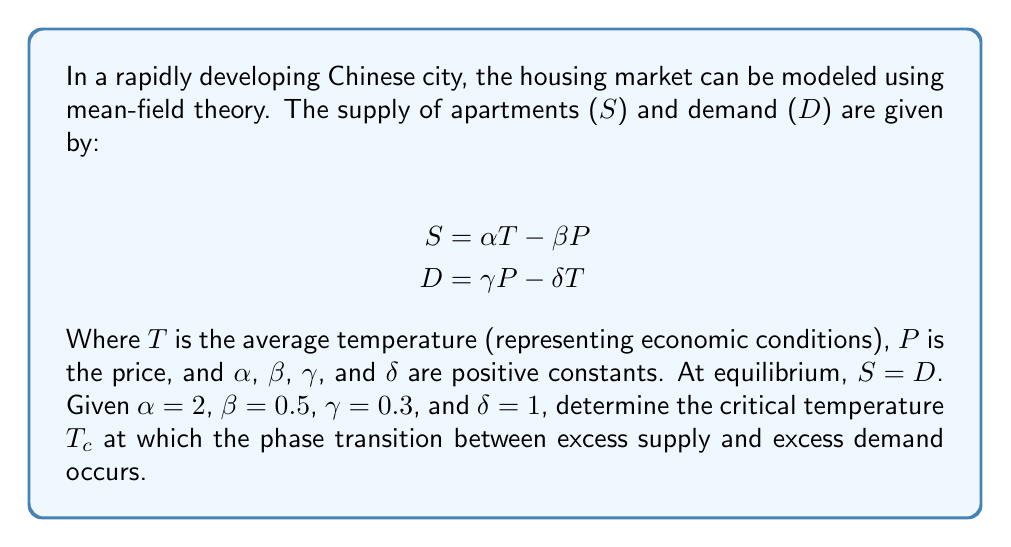Provide a solution to this math problem. To solve this problem, we'll follow these steps:

1) At equilibrium, supply equals demand:
   $$S = D$$
   $$\alpha T - \beta P = \gamma P - \delta T$$

2) Substitute the given values:
   $$2T - 0.5P = 0.3P - T$$

3) Rearrange the equation:
   $$3T = 0.8P$$
   $$T = \frac{0.8P}{3}$$

4) The critical point occurs when the slope of the supply curve equals the slope of the demand curve. To find this, we need to express $P$ in terms of $T$:
   $$S = \alpha T - \beta P$$
   $$P = \frac{\alpha T - S}{\beta}$$

5) The slope of the supply curve is:
   $$\frac{dS}{dT} = \alpha = 2$$

6) The slope of the demand curve is:
   $$\frac{dD}{dT} = -\delta = -1$$

7) At the critical point, these slopes are equal in magnitude:
   $$|\frac{dS}{dT}| = |\frac{dD}{dT}|$$
   $$2 = 1$$

8) This equality is always true for the given constants, which means the system is always at its critical point. The critical temperature $T_c$ is the temperature at which $S = D = 0$:

   $$0 = 2T_c - 0.5P$$
   $$0 = 0.3P - T_c$$

9) Solving these equations:
   $$T_c = 0.25P$$
   $$T_c = 0.3P$$

10) Equating these:
    $$0.25P = 0.3P$$
    $$P = 0$$

11) Substituting back:
    $$T_c = 0.25 * 0 = 0$$

Therefore, the critical temperature $T_c$ is 0.
Answer: $T_c = 0$ 